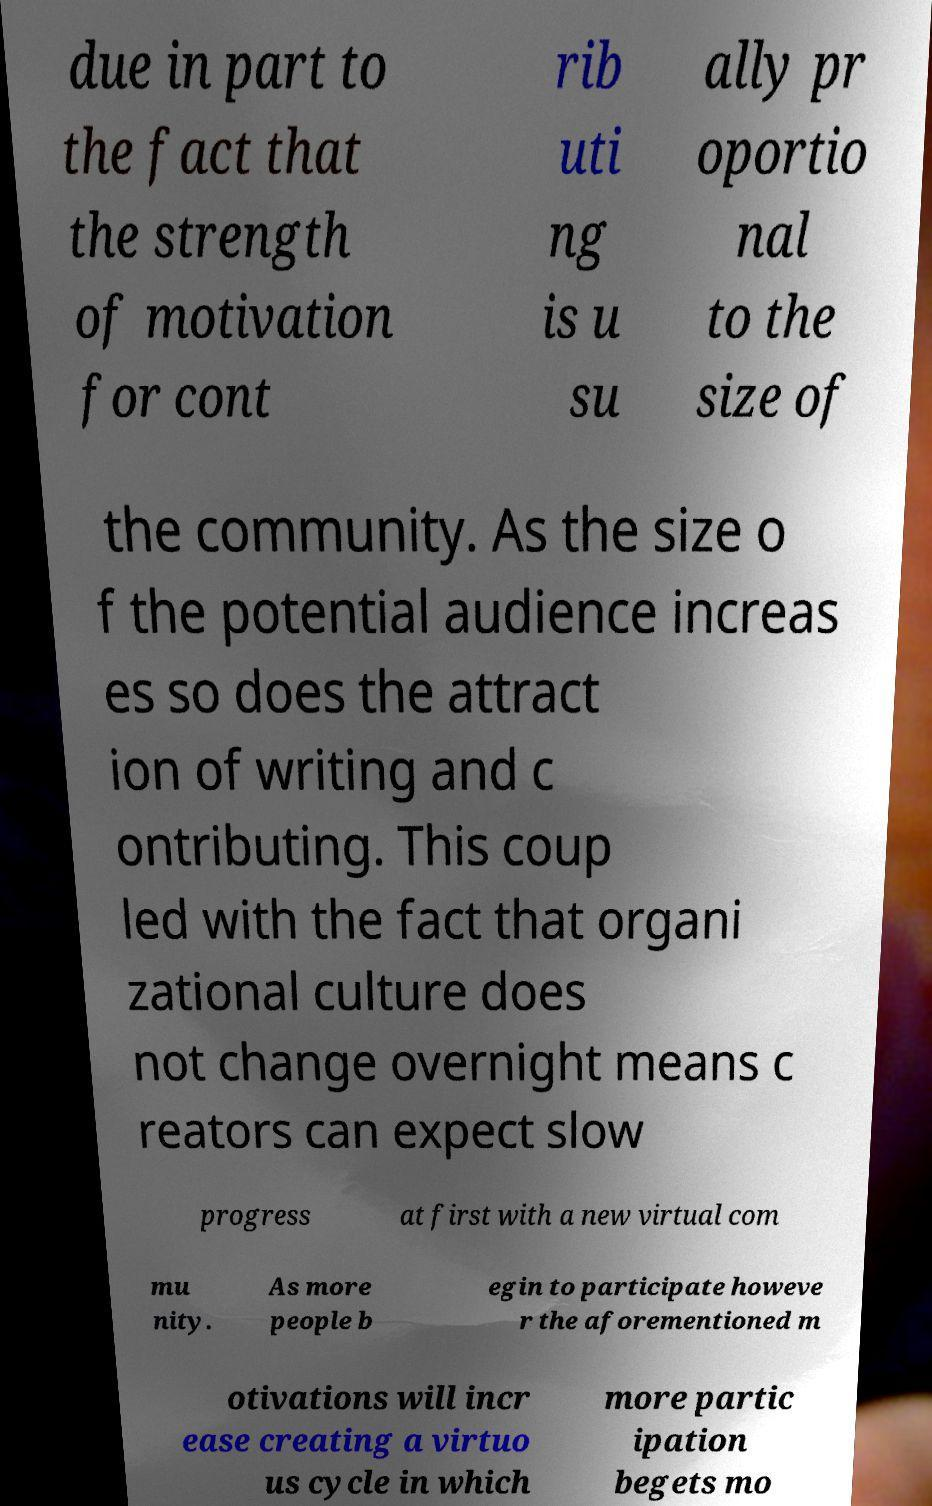Could you assist in decoding the text presented in this image and type it out clearly? due in part to the fact that the strength of motivation for cont rib uti ng is u su ally pr oportio nal to the size of the community. As the size o f the potential audience increas es so does the attract ion of writing and c ontributing. This coup led with the fact that organi zational culture does not change overnight means c reators can expect slow progress at first with a new virtual com mu nity. As more people b egin to participate howeve r the aforementioned m otivations will incr ease creating a virtuo us cycle in which more partic ipation begets mo 